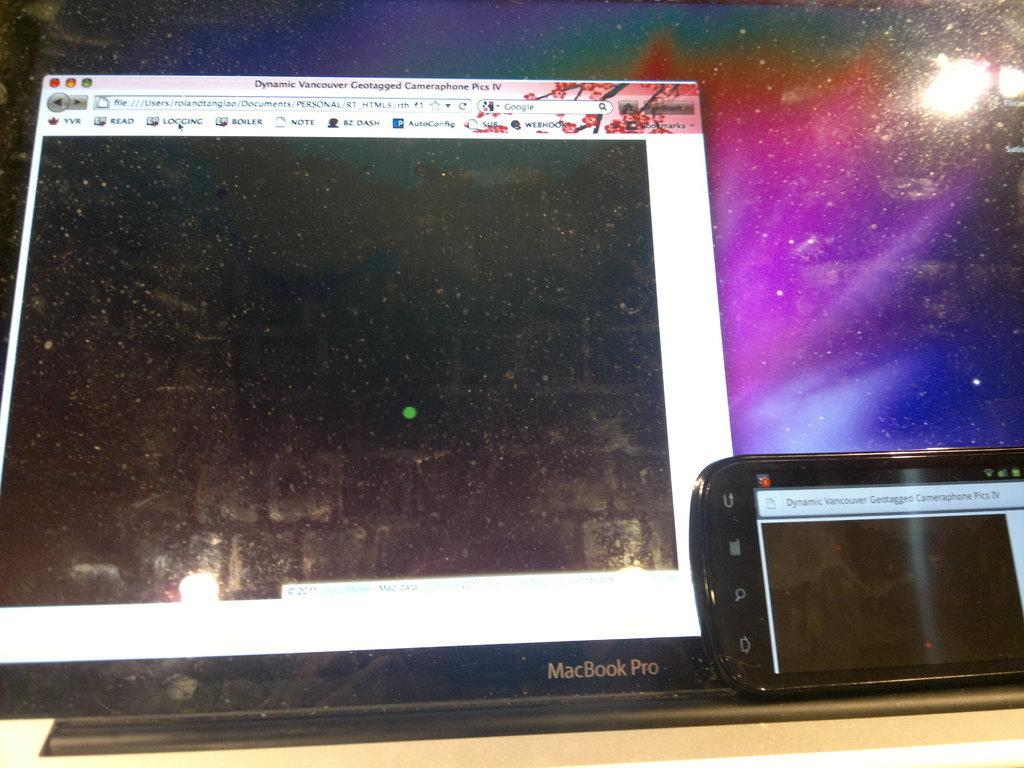<image>
Give a short and clear explanation of the subsequent image. the computer pictured here is a MacBook Pro 